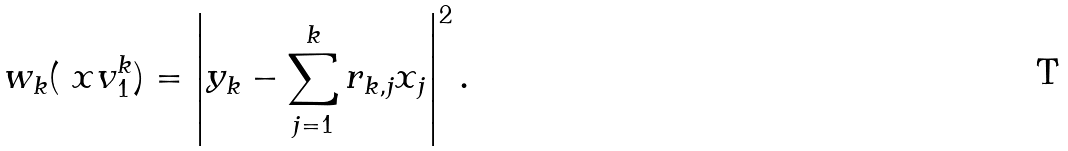Convert formula to latex. <formula><loc_0><loc_0><loc_500><loc_500>w _ { k } ( { \ x v } _ { 1 } ^ { k } ) = \left | y _ { k } - \sum _ { j = 1 } ^ { k } r _ { k , j } x _ { j } \right | ^ { 2 } .</formula> 